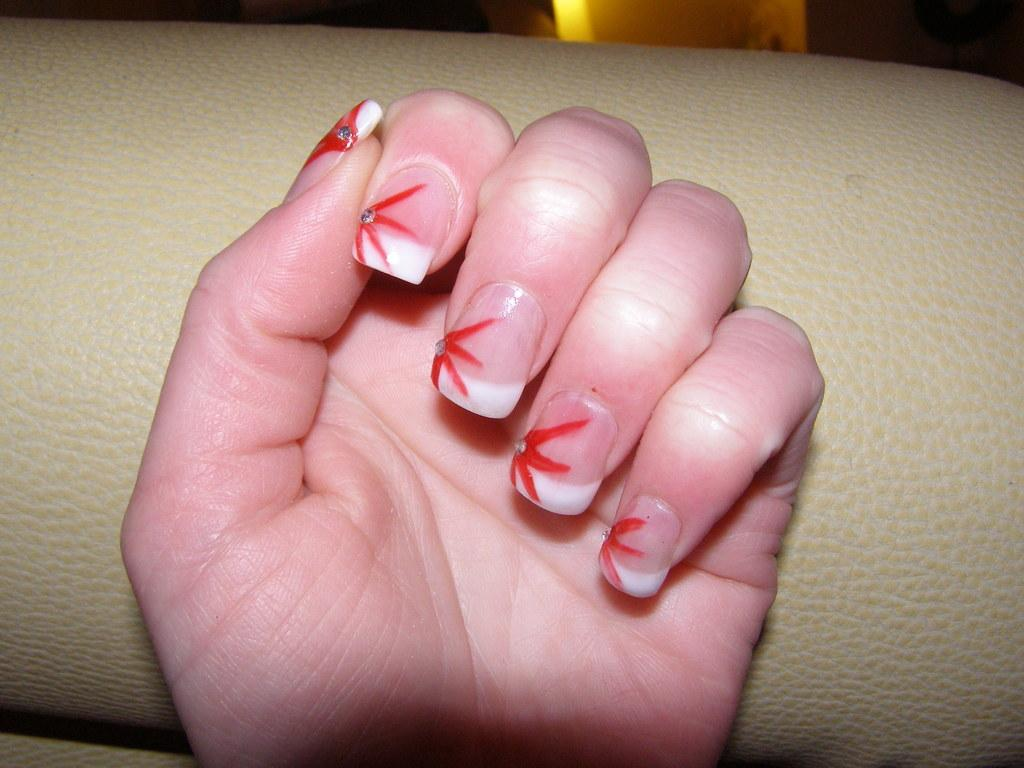What part of a person's body can be seen in the image? A person's hand is visible in the image. What is located behind the person's hand in the image? There is an object behind the person's hand in the image. How does the earthquake affect the arithmetic in the image? There is no earthquake or arithmetic present in the image; it only features a person's hand and an object behind it. 